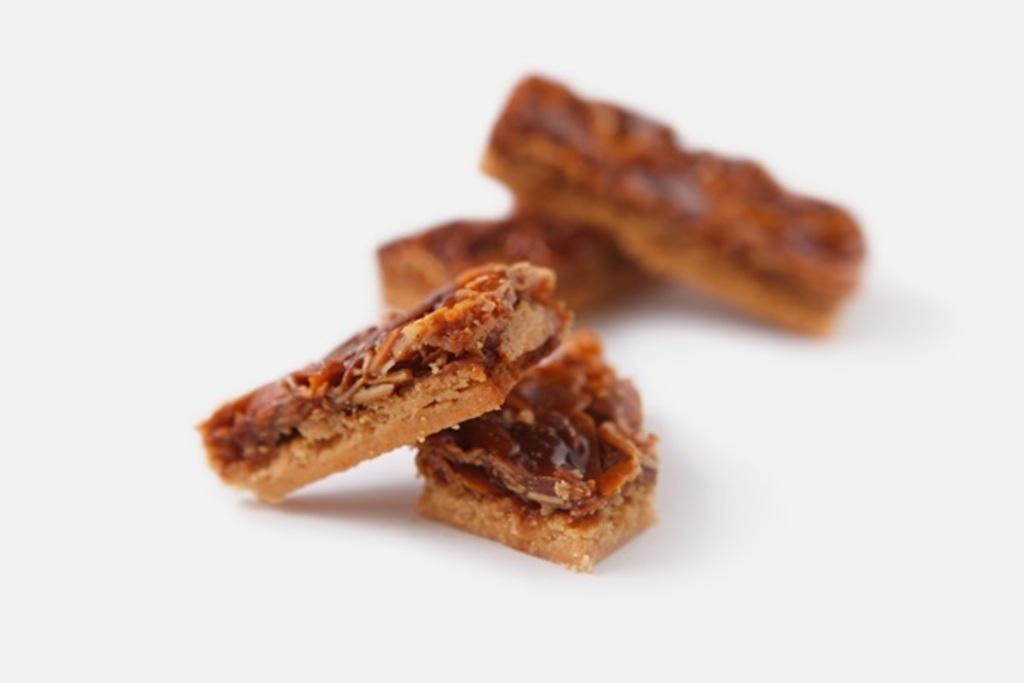Describe this image in one or two sentences. In this image we can see biscuits. 